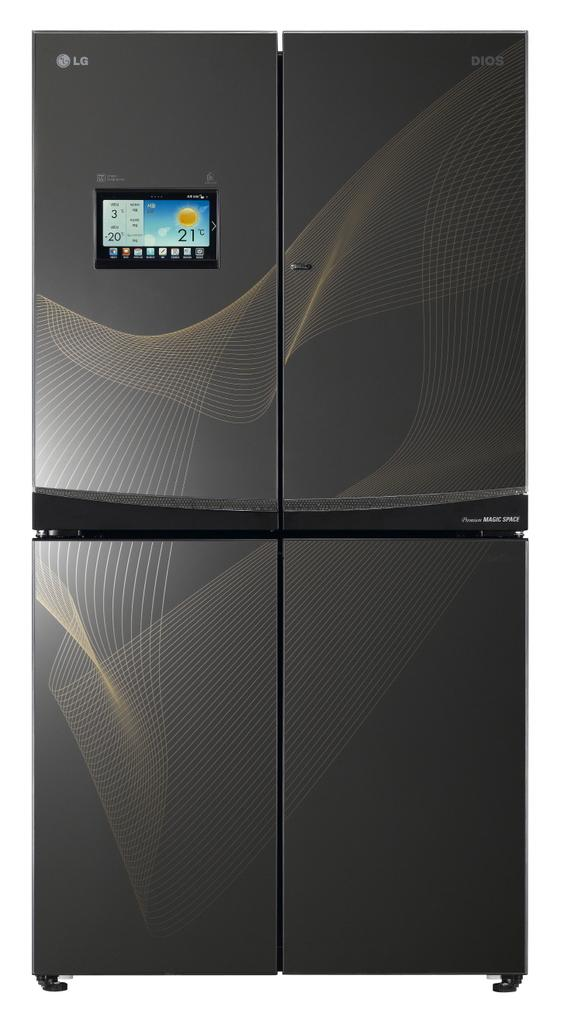<image>
Summarize the visual content of the image. An LG branded refrigerator with a digital screen on the front left door. 